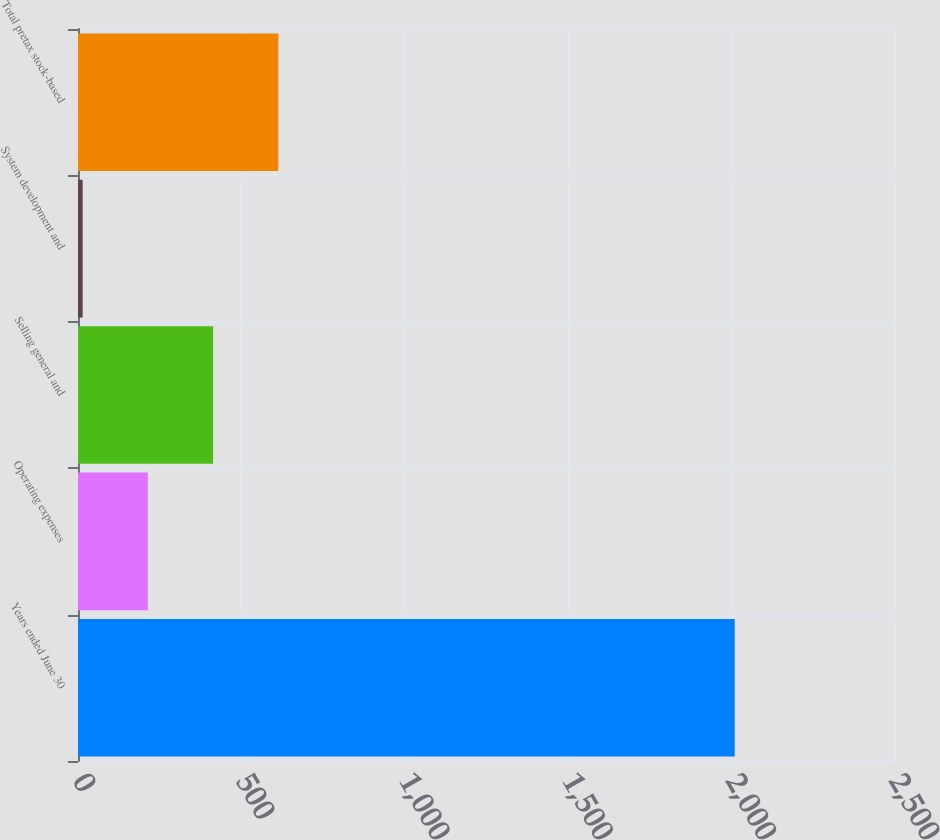<chart> <loc_0><loc_0><loc_500><loc_500><bar_chart><fcel>Years ended June 30<fcel>Operating expenses<fcel>Selling general and<fcel>System development and<fcel>Total pretax stock-based<nl><fcel>2012<fcel>214.07<fcel>413.84<fcel>14.3<fcel>613.61<nl></chart> 